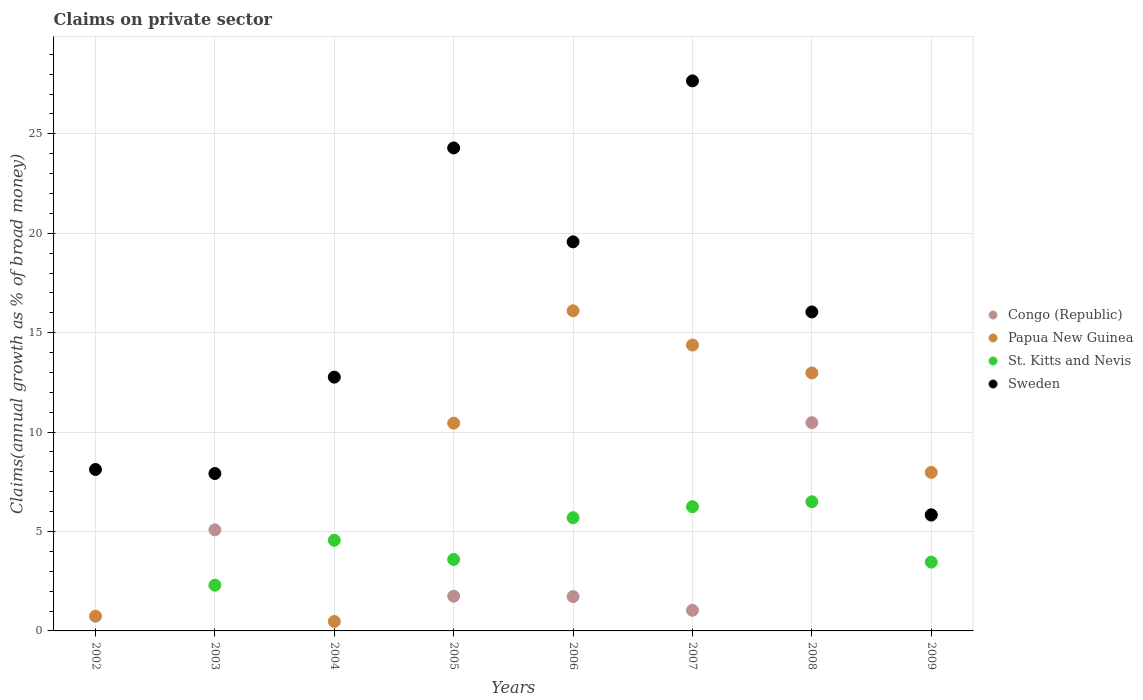How many different coloured dotlines are there?
Provide a short and direct response. 4. Is the number of dotlines equal to the number of legend labels?
Offer a terse response. No. What is the percentage of broad money claimed on private sector in Sweden in 2007?
Provide a succinct answer. 27.66. Across all years, what is the maximum percentage of broad money claimed on private sector in St. Kitts and Nevis?
Give a very brief answer. 6.5. Across all years, what is the minimum percentage of broad money claimed on private sector in Congo (Republic)?
Ensure brevity in your answer.  0. In which year was the percentage of broad money claimed on private sector in Congo (Republic) maximum?
Your answer should be compact. 2008. What is the total percentage of broad money claimed on private sector in St. Kitts and Nevis in the graph?
Your answer should be very brief. 32.35. What is the difference between the percentage of broad money claimed on private sector in Sweden in 2002 and that in 2007?
Give a very brief answer. -19.54. What is the difference between the percentage of broad money claimed on private sector in St. Kitts and Nevis in 2004 and the percentage of broad money claimed on private sector in Papua New Guinea in 2009?
Offer a terse response. -3.41. What is the average percentage of broad money claimed on private sector in Sweden per year?
Give a very brief answer. 15.28. In the year 2006, what is the difference between the percentage of broad money claimed on private sector in St. Kitts and Nevis and percentage of broad money claimed on private sector in Congo (Republic)?
Offer a very short reply. 3.97. What is the ratio of the percentage of broad money claimed on private sector in Sweden in 2007 to that in 2008?
Keep it short and to the point. 1.72. Is the percentage of broad money claimed on private sector in Papua New Guinea in 2006 less than that in 2008?
Your answer should be very brief. No. Is the difference between the percentage of broad money claimed on private sector in St. Kitts and Nevis in 2005 and 2006 greater than the difference between the percentage of broad money claimed on private sector in Congo (Republic) in 2005 and 2006?
Keep it short and to the point. No. What is the difference between the highest and the second highest percentage of broad money claimed on private sector in Papua New Guinea?
Offer a terse response. 1.72. What is the difference between the highest and the lowest percentage of broad money claimed on private sector in Congo (Republic)?
Your response must be concise. 10.47. In how many years, is the percentage of broad money claimed on private sector in Papua New Guinea greater than the average percentage of broad money claimed on private sector in Papua New Guinea taken over all years?
Offer a terse response. 5. Is the sum of the percentage of broad money claimed on private sector in Papua New Guinea in 2004 and 2007 greater than the maximum percentage of broad money claimed on private sector in Congo (Republic) across all years?
Keep it short and to the point. Yes. Is it the case that in every year, the sum of the percentage of broad money claimed on private sector in St. Kitts and Nevis and percentage of broad money claimed on private sector in Congo (Republic)  is greater than the sum of percentage of broad money claimed on private sector in Sweden and percentage of broad money claimed on private sector in Papua New Guinea?
Make the answer very short. No. Is the percentage of broad money claimed on private sector in St. Kitts and Nevis strictly greater than the percentage of broad money claimed on private sector in Congo (Republic) over the years?
Keep it short and to the point. No. Is the percentage of broad money claimed on private sector in Papua New Guinea strictly less than the percentage of broad money claimed on private sector in Sweden over the years?
Your answer should be very brief. No. Does the graph contain any zero values?
Provide a short and direct response. Yes. Where does the legend appear in the graph?
Ensure brevity in your answer.  Center right. How many legend labels are there?
Give a very brief answer. 4. What is the title of the graph?
Keep it short and to the point. Claims on private sector. Does "Middle East & North Africa (developing only)" appear as one of the legend labels in the graph?
Offer a terse response. No. What is the label or title of the Y-axis?
Provide a succinct answer. Claims(annual growth as % of broad money). What is the Claims(annual growth as % of broad money) of Congo (Republic) in 2002?
Provide a succinct answer. 0. What is the Claims(annual growth as % of broad money) of Papua New Guinea in 2002?
Offer a very short reply. 0.74. What is the Claims(annual growth as % of broad money) in St. Kitts and Nevis in 2002?
Provide a succinct answer. 0. What is the Claims(annual growth as % of broad money) of Sweden in 2002?
Ensure brevity in your answer.  8.12. What is the Claims(annual growth as % of broad money) in Congo (Republic) in 2003?
Your answer should be compact. 5.08. What is the Claims(annual growth as % of broad money) in Papua New Guinea in 2003?
Your response must be concise. 0. What is the Claims(annual growth as % of broad money) of St. Kitts and Nevis in 2003?
Give a very brief answer. 2.3. What is the Claims(annual growth as % of broad money) of Sweden in 2003?
Your answer should be compact. 7.92. What is the Claims(annual growth as % of broad money) of Congo (Republic) in 2004?
Ensure brevity in your answer.  0. What is the Claims(annual growth as % of broad money) of Papua New Guinea in 2004?
Give a very brief answer. 0.48. What is the Claims(annual growth as % of broad money) of St. Kitts and Nevis in 2004?
Your answer should be compact. 4.56. What is the Claims(annual growth as % of broad money) in Sweden in 2004?
Provide a short and direct response. 12.76. What is the Claims(annual growth as % of broad money) of Congo (Republic) in 2005?
Provide a short and direct response. 1.75. What is the Claims(annual growth as % of broad money) in Papua New Guinea in 2005?
Give a very brief answer. 10.45. What is the Claims(annual growth as % of broad money) in St. Kitts and Nevis in 2005?
Give a very brief answer. 3.6. What is the Claims(annual growth as % of broad money) of Sweden in 2005?
Offer a very short reply. 24.29. What is the Claims(annual growth as % of broad money) in Congo (Republic) in 2006?
Offer a very short reply. 1.73. What is the Claims(annual growth as % of broad money) in Papua New Guinea in 2006?
Provide a succinct answer. 16.1. What is the Claims(annual growth as % of broad money) in St. Kitts and Nevis in 2006?
Give a very brief answer. 5.69. What is the Claims(annual growth as % of broad money) in Sweden in 2006?
Provide a short and direct response. 19.57. What is the Claims(annual growth as % of broad money) in Congo (Republic) in 2007?
Offer a very short reply. 1.04. What is the Claims(annual growth as % of broad money) of Papua New Guinea in 2007?
Ensure brevity in your answer.  14.38. What is the Claims(annual growth as % of broad money) in St. Kitts and Nevis in 2007?
Give a very brief answer. 6.25. What is the Claims(annual growth as % of broad money) in Sweden in 2007?
Offer a terse response. 27.66. What is the Claims(annual growth as % of broad money) of Congo (Republic) in 2008?
Provide a succinct answer. 10.47. What is the Claims(annual growth as % of broad money) of Papua New Guinea in 2008?
Your response must be concise. 12.98. What is the Claims(annual growth as % of broad money) of St. Kitts and Nevis in 2008?
Keep it short and to the point. 6.5. What is the Claims(annual growth as % of broad money) of Sweden in 2008?
Offer a very short reply. 16.04. What is the Claims(annual growth as % of broad money) in Congo (Republic) in 2009?
Give a very brief answer. 5.81. What is the Claims(annual growth as % of broad money) in Papua New Guinea in 2009?
Your response must be concise. 7.97. What is the Claims(annual growth as % of broad money) of St. Kitts and Nevis in 2009?
Make the answer very short. 3.46. What is the Claims(annual growth as % of broad money) of Sweden in 2009?
Provide a short and direct response. 5.84. Across all years, what is the maximum Claims(annual growth as % of broad money) in Congo (Republic)?
Keep it short and to the point. 10.47. Across all years, what is the maximum Claims(annual growth as % of broad money) of Papua New Guinea?
Ensure brevity in your answer.  16.1. Across all years, what is the maximum Claims(annual growth as % of broad money) in St. Kitts and Nevis?
Provide a succinct answer. 6.5. Across all years, what is the maximum Claims(annual growth as % of broad money) of Sweden?
Your answer should be very brief. 27.66. Across all years, what is the minimum Claims(annual growth as % of broad money) in Congo (Republic)?
Offer a very short reply. 0. Across all years, what is the minimum Claims(annual growth as % of broad money) of Papua New Guinea?
Your answer should be compact. 0. Across all years, what is the minimum Claims(annual growth as % of broad money) of Sweden?
Keep it short and to the point. 5.84. What is the total Claims(annual growth as % of broad money) of Congo (Republic) in the graph?
Offer a very short reply. 25.88. What is the total Claims(annual growth as % of broad money) of Papua New Guinea in the graph?
Provide a succinct answer. 63.09. What is the total Claims(annual growth as % of broad money) of St. Kitts and Nevis in the graph?
Give a very brief answer. 32.35. What is the total Claims(annual growth as % of broad money) of Sweden in the graph?
Keep it short and to the point. 122.21. What is the difference between the Claims(annual growth as % of broad money) in Sweden in 2002 and that in 2003?
Provide a short and direct response. 0.2. What is the difference between the Claims(annual growth as % of broad money) in Papua New Guinea in 2002 and that in 2004?
Offer a terse response. 0.27. What is the difference between the Claims(annual growth as % of broad money) of Sweden in 2002 and that in 2004?
Your answer should be compact. -4.64. What is the difference between the Claims(annual growth as % of broad money) in Papua New Guinea in 2002 and that in 2005?
Offer a very short reply. -9.71. What is the difference between the Claims(annual growth as % of broad money) in Sweden in 2002 and that in 2005?
Offer a very short reply. -16.17. What is the difference between the Claims(annual growth as % of broad money) of Papua New Guinea in 2002 and that in 2006?
Provide a short and direct response. -15.36. What is the difference between the Claims(annual growth as % of broad money) in Sweden in 2002 and that in 2006?
Offer a terse response. -11.45. What is the difference between the Claims(annual growth as % of broad money) in Papua New Guinea in 2002 and that in 2007?
Keep it short and to the point. -13.64. What is the difference between the Claims(annual growth as % of broad money) of Sweden in 2002 and that in 2007?
Keep it short and to the point. -19.54. What is the difference between the Claims(annual growth as % of broad money) in Papua New Guinea in 2002 and that in 2008?
Provide a succinct answer. -12.24. What is the difference between the Claims(annual growth as % of broad money) of Sweden in 2002 and that in 2008?
Your response must be concise. -7.92. What is the difference between the Claims(annual growth as % of broad money) in Papua New Guinea in 2002 and that in 2009?
Offer a very short reply. -7.23. What is the difference between the Claims(annual growth as % of broad money) in Sweden in 2002 and that in 2009?
Offer a very short reply. 2.28. What is the difference between the Claims(annual growth as % of broad money) in St. Kitts and Nevis in 2003 and that in 2004?
Provide a short and direct response. -2.26. What is the difference between the Claims(annual growth as % of broad money) of Sweden in 2003 and that in 2004?
Your response must be concise. -4.85. What is the difference between the Claims(annual growth as % of broad money) of Congo (Republic) in 2003 and that in 2005?
Make the answer very short. 3.34. What is the difference between the Claims(annual growth as % of broad money) in St. Kitts and Nevis in 2003 and that in 2005?
Offer a very short reply. -1.3. What is the difference between the Claims(annual growth as % of broad money) of Sweden in 2003 and that in 2005?
Keep it short and to the point. -16.38. What is the difference between the Claims(annual growth as % of broad money) of Congo (Republic) in 2003 and that in 2006?
Make the answer very short. 3.36. What is the difference between the Claims(annual growth as % of broad money) in St. Kitts and Nevis in 2003 and that in 2006?
Your answer should be compact. -3.39. What is the difference between the Claims(annual growth as % of broad money) in Sweden in 2003 and that in 2006?
Ensure brevity in your answer.  -11.65. What is the difference between the Claims(annual growth as % of broad money) in Congo (Republic) in 2003 and that in 2007?
Offer a very short reply. 4.04. What is the difference between the Claims(annual growth as % of broad money) in St. Kitts and Nevis in 2003 and that in 2007?
Give a very brief answer. -3.95. What is the difference between the Claims(annual growth as % of broad money) of Sweden in 2003 and that in 2007?
Make the answer very short. -19.75. What is the difference between the Claims(annual growth as % of broad money) of Congo (Republic) in 2003 and that in 2008?
Make the answer very short. -5.39. What is the difference between the Claims(annual growth as % of broad money) of St. Kitts and Nevis in 2003 and that in 2008?
Offer a terse response. -4.2. What is the difference between the Claims(annual growth as % of broad money) of Sweden in 2003 and that in 2008?
Ensure brevity in your answer.  -8.13. What is the difference between the Claims(annual growth as % of broad money) of Congo (Republic) in 2003 and that in 2009?
Offer a very short reply. -0.73. What is the difference between the Claims(annual growth as % of broad money) of St. Kitts and Nevis in 2003 and that in 2009?
Provide a short and direct response. -1.16. What is the difference between the Claims(annual growth as % of broad money) of Sweden in 2003 and that in 2009?
Your answer should be compact. 2.07. What is the difference between the Claims(annual growth as % of broad money) of Papua New Guinea in 2004 and that in 2005?
Provide a short and direct response. -9.98. What is the difference between the Claims(annual growth as % of broad money) in St. Kitts and Nevis in 2004 and that in 2005?
Give a very brief answer. 0.96. What is the difference between the Claims(annual growth as % of broad money) of Sweden in 2004 and that in 2005?
Provide a short and direct response. -11.53. What is the difference between the Claims(annual growth as % of broad money) in Papua New Guinea in 2004 and that in 2006?
Provide a short and direct response. -15.62. What is the difference between the Claims(annual growth as % of broad money) of St. Kitts and Nevis in 2004 and that in 2006?
Ensure brevity in your answer.  -1.13. What is the difference between the Claims(annual growth as % of broad money) of Sweden in 2004 and that in 2006?
Make the answer very short. -6.8. What is the difference between the Claims(annual growth as % of broad money) of Papua New Guinea in 2004 and that in 2007?
Provide a short and direct response. -13.9. What is the difference between the Claims(annual growth as % of broad money) of St. Kitts and Nevis in 2004 and that in 2007?
Provide a short and direct response. -1.69. What is the difference between the Claims(annual growth as % of broad money) of Sweden in 2004 and that in 2007?
Your answer should be compact. -14.9. What is the difference between the Claims(annual growth as % of broad money) in Papua New Guinea in 2004 and that in 2008?
Your response must be concise. -12.5. What is the difference between the Claims(annual growth as % of broad money) in St. Kitts and Nevis in 2004 and that in 2008?
Provide a succinct answer. -1.94. What is the difference between the Claims(annual growth as % of broad money) of Sweden in 2004 and that in 2008?
Your response must be concise. -3.28. What is the difference between the Claims(annual growth as % of broad money) in Papua New Guinea in 2004 and that in 2009?
Your answer should be very brief. -7.5. What is the difference between the Claims(annual growth as % of broad money) of St. Kitts and Nevis in 2004 and that in 2009?
Ensure brevity in your answer.  1.1. What is the difference between the Claims(annual growth as % of broad money) in Sweden in 2004 and that in 2009?
Your answer should be compact. 6.92. What is the difference between the Claims(annual growth as % of broad money) of Congo (Republic) in 2005 and that in 2006?
Give a very brief answer. 0.02. What is the difference between the Claims(annual growth as % of broad money) of Papua New Guinea in 2005 and that in 2006?
Give a very brief answer. -5.65. What is the difference between the Claims(annual growth as % of broad money) of St. Kitts and Nevis in 2005 and that in 2006?
Keep it short and to the point. -2.1. What is the difference between the Claims(annual growth as % of broad money) of Sweden in 2005 and that in 2006?
Provide a short and direct response. 4.72. What is the difference between the Claims(annual growth as % of broad money) of Congo (Republic) in 2005 and that in 2007?
Give a very brief answer. 0.71. What is the difference between the Claims(annual growth as % of broad money) in Papua New Guinea in 2005 and that in 2007?
Make the answer very short. -3.93. What is the difference between the Claims(annual growth as % of broad money) in St. Kitts and Nevis in 2005 and that in 2007?
Give a very brief answer. -2.65. What is the difference between the Claims(annual growth as % of broad money) in Sweden in 2005 and that in 2007?
Offer a terse response. -3.37. What is the difference between the Claims(annual growth as % of broad money) in Congo (Republic) in 2005 and that in 2008?
Your answer should be compact. -8.73. What is the difference between the Claims(annual growth as % of broad money) of Papua New Guinea in 2005 and that in 2008?
Ensure brevity in your answer.  -2.53. What is the difference between the Claims(annual growth as % of broad money) in St. Kitts and Nevis in 2005 and that in 2008?
Give a very brief answer. -2.9. What is the difference between the Claims(annual growth as % of broad money) of Sweden in 2005 and that in 2008?
Provide a short and direct response. 8.25. What is the difference between the Claims(annual growth as % of broad money) in Congo (Republic) in 2005 and that in 2009?
Your answer should be compact. -4.06. What is the difference between the Claims(annual growth as % of broad money) in Papua New Guinea in 2005 and that in 2009?
Keep it short and to the point. 2.48. What is the difference between the Claims(annual growth as % of broad money) in St. Kitts and Nevis in 2005 and that in 2009?
Your answer should be compact. 0.14. What is the difference between the Claims(annual growth as % of broad money) of Sweden in 2005 and that in 2009?
Ensure brevity in your answer.  18.45. What is the difference between the Claims(annual growth as % of broad money) of Congo (Republic) in 2006 and that in 2007?
Make the answer very short. 0.69. What is the difference between the Claims(annual growth as % of broad money) in Papua New Guinea in 2006 and that in 2007?
Offer a terse response. 1.72. What is the difference between the Claims(annual growth as % of broad money) in St. Kitts and Nevis in 2006 and that in 2007?
Keep it short and to the point. -0.55. What is the difference between the Claims(annual growth as % of broad money) of Sweden in 2006 and that in 2007?
Provide a short and direct response. -8.09. What is the difference between the Claims(annual growth as % of broad money) in Congo (Republic) in 2006 and that in 2008?
Ensure brevity in your answer.  -8.75. What is the difference between the Claims(annual growth as % of broad money) of Papua New Guinea in 2006 and that in 2008?
Your response must be concise. 3.12. What is the difference between the Claims(annual growth as % of broad money) of St. Kitts and Nevis in 2006 and that in 2008?
Give a very brief answer. -0.8. What is the difference between the Claims(annual growth as % of broad money) in Sweden in 2006 and that in 2008?
Your response must be concise. 3.53. What is the difference between the Claims(annual growth as % of broad money) in Congo (Republic) in 2006 and that in 2009?
Ensure brevity in your answer.  -4.08. What is the difference between the Claims(annual growth as % of broad money) in Papua New Guinea in 2006 and that in 2009?
Your answer should be very brief. 8.13. What is the difference between the Claims(annual growth as % of broad money) in St. Kitts and Nevis in 2006 and that in 2009?
Provide a succinct answer. 2.23. What is the difference between the Claims(annual growth as % of broad money) of Sweden in 2006 and that in 2009?
Ensure brevity in your answer.  13.73. What is the difference between the Claims(annual growth as % of broad money) in Congo (Republic) in 2007 and that in 2008?
Your answer should be compact. -9.44. What is the difference between the Claims(annual growth as % of broad money) of Papua New Guinea in 2007 and that in 2008?
Offer a terse response. 1.4. What is the difference between the Claims(annual growth as % of broad money) in St. Kitts and Nevis in 2007 and that in 2008?
Your answer should be very brief. -0.25. What is the difference between the Claims(annual growth as % of broad money) in Sweden in 2007 and that in 2008?
Your answer should be compact. 11.62. What is the difference between the Claims(annual growth as % of broad money) of Congo (Republic) in 2007 and that in 2009?
Keep it short and to the point. -4.77. What is the difference between the Claims(annual growth as % of broad money) of Papua New Guinea in 2007 and that in 2009?
Keep it short and to the point. 6.41. What is the difference between the Claims(annual growth as % of broad money) in St. Kitts and Nevis in 2007 and that in 2009?
Your answer should be compact. 2.79. What is the difference between the Claims(annual growth as % of broad money) of Sweden in 2007 and that in 2009?
Give a very brief answer. 21.82. What is the difference between the Claims(annual growth as % of broad money) of Congo (Republic) in 2008 and that in 2009?
Make the answer very short. 4.67. What is the difference between the Claims(annual growth as % of broad money) in Papua New Guinea in 2008 and that in 2009?
Provide a short and direct response. 5. What is the difference between the Claims(annual growth as % of broad money) in St. Kitts and Nevis in 2008 and that in 2009?
Keep it short and to the point. 3.04. What is the difference between the Claims(annual growth as % of broad money) in Sweden in 2008 and that in 2009?
Make the answer very short. 10.2. What is the difference between the Claims(annual growth as % of broad money) of Papua New Guinea in 2002 and the Claims(annual growth as % of broad money) of St. Kitts and Nevis in 2003?
Give a very brief answer. -1.56. What is the difference between the Claims(annual growth as % of broad money) in Papua New Guinea in 2002 and the Claims(annual growth as % of broad money) in Sweden in 2003?
Give a very brief answer. -7.18. What is the difference between the Claims(annual growth as % of broad money) in Papua New Guinea in 2002 and the Claims(annual growth as % of broad money) in St. Kitts and Nevis in 2004?
Keep it short and to the point. -3.82. What is the difference between the Claims(annual growth as % of broad money) in Papua New Guinea in 2002 and the Claims(annual growth as % of broad money) in Sweden in 2004?
Provide a short and direct response. -12.02. What is the difference between the Claims(annual growth as % of broad money) in Papua New Guinea in 2002 and the Claims(annual growth as % of broad money) in St. Kitts and Nevis in 2005?
Provide a succinct answer. -2.85. What is the difference between the Claims(annual growth as % of broad money) of Papua New Guinea in 2002 and the Claims(annual growth as % of broad money) of Sweden in 2005?
Your response must be concise. -23.55. What is the difference between the Claims(annual growth as % of broad money) in Papua New Guinea in 2002 and the Claims(annual growth as % of broad money) in St. Kitts and Nevis in 2006?
Keep it short and to the point. -4.95. What is the difference between the Claims(annual growth as % of broad money) of Papua New Guinea in 2002 and the Claims(annual growth as % of broad money) of Sweden in 2006?
Offer a terse response. -18.83. What is the difference between the Claims(annual growth as % of broad money) of Papua New Guinea in 2002 and the Claims(annual growth as % of broad money) of St. Kitts and Nevis in 2007?
Make the answer very short. -5.51. What is the difference between the Claims(annual growth as % of broad money) of Papua New Guinea in 2002 and the Claims(annual growth as % of broad money) of Sweden in 2007?
Make the answer very short. -26.92. What is the difference between the Claims(annual growth as % of broad money) in Papua New Guinea in 2002 and the Claims(annual growth as % of broad money) in St. Kitts and Nevis in 2008?
Offer a terse response. -5.75. What is the difference between the Claims(annual growth as % of broad money) of Papua New Guinea in 2002 and the Claims(annual growth as % of broad money) of Sweden in 2008?
Give a very brief answer. -15.3. What is the difference between the Claims(annual growth as % of broad money) of Papua New Guinea in 2002 and the Claims(annual growth as % of broad money) of St. Kitts and Nevis in 2009?
Your answer should be compact. -2.72. What is the difference between the Claims(annual growth as % of broad money) in Papua New Guinea in 2002 and the Claims(annual growth as % of broad money) in Sweden in 2009?
Your answer should be compact. -5.1. What is the difference between the Claims(annual growth as % of broad money) in Congo (Republic) in 2003 and the Claims(annual growth as % of broad money) in Papua New Guinea in 2004?
Your answer should be compact. 4.61. What is the difference between the Claims(annual growth as % of broad money) of Congo (Republic) in 2003 and the Claims(annual growth as % of broad money) of St. Kitts and Nevis in 2004?
Your response must be concise. 0.52. What is the difference between the Claims(annual growth as % of broad money) in Congo (Republic) in 2003 and the Claims(annual growth as % of broad money) in Sweden in 2004?
Ensure brevity in your answer.  -7.68. What is the difference between the Claims(annual growth as % of broad money) of St. Kitts and Nevis in 2003 and the Claims(annual growth as % of broad money) of Sweden in 2004?
Provide a succinct answer. -10.46. What is the difference between the Claims(annual growth as % of broad money) of Congo (Republic) in 2003 and the Claims(annual growth as % of broad money) of Papua New Guinea in 2005?
Provide a succinct answer. -5.37. What is the difference between the Claims(annual growth as % of broad money) of Congo (Republic) in 2003 and the Claims(annual growth as % of broad money) of St. Kitts and Nevis in 2005?
Provide a succinct answer. 1.49. What is the difference between the Claims(annual growth as % of broad money) in Congo (Republic) in 2003 and the Claims(annual growth as % of broad money) in Sweden in 2005?
Keep it short and to the point. -19.21. What is the difference between the Claims(annual growth as % of broad money) in St. Kitts and Nevis in 2003 and the Claims(annual growth as % of broad money) in Sweden in 2005?
Your answer should be compact. -21.99. What is the difference between the Claims(annual growth as % of broad money) in Congo (Republic) in 2003 and the Claims(annual growth as % of broad money) in Papua New Guinea in 2006?
Make the answer very short. -11.02. What is the difference between the Claims(annual growth as % of broad money) in Congo (Republic) in 2003 and the Claims(annual growth as % of broad money) in St. Kitts and Nevis in 2006?
Make the answer very short. -0.61. What is the difference between the Claims(annual growth as % of broad money) of Congo (Republic) in 2003 and the Claims(annual growth as % of broad money) of Sweden in 2006?
Make the answer very short. -14.49. What is the difference between the Claims(annual growth as % of broad money) of St. Kitts and Nevis in 2003 and the Claims(annual growth as % of broad money) of Sweden in 2006?
Provide a short and direct response. -17.27. What is the difference between the Claims(annual growth as % of broad money) of Congo (Republic) in 2003 and the Claims(annual growth as % of broad money) of Papua New Guinea in 2007?
Ensure brevity in your answer.  -9.3. What is the difference between the Claims(annual growth as % of broad money) in Congo (Republic) in 2003 and the Claims(annual growth as % of broad money) in St. Kitts and Nevis in 2007?
Provide a short and direct response. -1.16. What is the difference between the Claims(annual growth as % of broad money) in Congo (Republic) in 2003 and the Claims(annual growth as % of broad money) in Sweden in 2007?
Ensure brevity in your answer.  -22.58. What is the difference between the Claims(annual growth as % of broad money) of St. Kitts and Nevis in 2003 and the Claims(annual growth as % of broad money) of Sweden in 2007?
Your answer should be compact. -25.36. What is the difference between the Claims(annual growth as % of broad money) of Congo (Republic) in 2003 and the Claims(annual growth as % of broad money) of Papua New Guinea in 2008?
Keep it short and to the point. -7.89. What is the difference between the Claims(annual growth as % of broad money) in Congo (Republic) in 2003 and the Claims(annual growth as % of broad money) in St. Kitts and Nevis in 2008?
Offer a terse response. -1.41. What is the difference between the Claims(annual growth as % of broad money) in Congo (Republic) in 2003 and the Claims(annual growth as % of broad money) in Sweden in 2008?
Give a very brief answer. -10.96. What is the difference between the Claims(annual growth as % of broad money) in St. Kitts and Nevis in 2003 and the Claims(annual growth as % of broad money) in Sweden in 2008?
Provide a succinct answer. -13.74. What is the difference between the Claims(annual growth as % of broad money) of Congo (Republic) in 2003 and the Claims(annual growth as % of broad money) of Papua New Guinea in 2009?
Your response must be concise. -2.89. What is the difference between the Claims(annual growth as % of broad money) of Congo (Republic) in 2003 and the Claims(annual growth as % of broad money) of St. Kitts and Nevis in 2009?
Offer a very short reply. 1.62. What is the difference between the Claims(annual growth as % of broad money) in Congo (Republic) in 2003 and the Claims(annual growth as % of broad money) in Sweden in 2009?
Make the answer very short. -0.76. What is the difference between the Claims(annual growth as % of broad money) of St. Kitts and Nevis in 2003 and the Claims(annual growth as % of broad money) of Sweden in 2009?
Ensure brevity in your answer.  -3.54. What is the difference between the Claims(annual growth as % of broad money) of Papua New Guinea in 2004 and the Claims(annual growth as % of broad money) of St. Kitts and Nevis in 2005?
Keep it short and to the point. -3.12. What is the difference between the Claims(annual growth as % of broad money) of Papua New Guinea in 2004 and the Claims(annual growth as % of broad money) of Sweden in 2005?
Provide a succinct answer. -23.82. What is the difference between the Claims(annual growth as % of broad money) in St. Kitts and Nevis in 2004 and the Claims(annual growth as % of broad money) in Sweden in 2005?
Your answer should be very brief. -19.73. What is the difference between the Claims(annual growth as % of broad money) in Papua New Guinea in 2004 and the Claims(annual growth as % of broad money) in St. Kitts and Nevis in 2006?
Provide a short and direct response. -5.22. What is the difference between the Claims(annual growth as % of broad money) of Papua New Guinea in 2004 and the Claims(annual growth as % of broad money) of Sweden in 2006?
Provide a succinct answer. -19.09. What is the difference between the Claims(annual growth as % of broad money) of St. Kitts and Nevis in 2004 and the Claims(annual growth as % of broad money) of Sweden in 2006?
Offer a terse response. -15.01. What is the difference between the Claims(annual growth as % of broad money) in Papua New Guinea in 2004 and the Claims(annual growth as % of broad money) in St. Kitts and Nevis in 2007?
Provide a succinct answer. -5.77. What is the difference between the Claims(annual growth as % of broad money) of Papua New Guinea in 2004 and the Claims(annual growth as % of broad money) of Sweden in 2007?
Offer a terse response. -27.19. What is the difference between the Claims(annual growth as % of broad money) of St. Kitts and Nevis in 2004 and the Claims(annual growth as % of broad money) of Sweden in 2007?
Make the answer very short. -23.1. What is the difference between the Claims(annual growth as % of broad money) in Papua New Guinea in 2004 and the Claims(annual growth as % of broad money) in St. Kitts and Nevis in 2008?
Your answer should be compact. -6.02. What is the difference between the Claims(annual growth as % of broad money) in Papua New Guinea in 2004 and the Claims(annual growth as % of broad money) in Sweden in 2008?
Your answer should be compact. -15.57. What is the difference between the Claims(annual growth as % of broad money) in St. Kitts and Nevis in 2004 and the Claims(annual growth as % of broad money) in Sweden in 2008?
Ensure brevity in your answer.  -11.48. What is the difference between the Claims(annual growth as % of broad money) of Papua New Guinea in 2004 and the Claims(annual growth as % of broad money) of St. Kitts and Nevis in 2009?
Offer a terse response. -2.98. What is the difference between the Claims(annual growth as % of broad money) of Papua New Guinea in 2004 and the Claims(annual growth as % of broad money) of Sweden in 2009?
Your answer should be compact. -5.37. What is the difference between the Claims(annual growth as % of broad money) of St. Kitts and Nevis in 2004 and the Claims(annual growth as % of broad money) of Sweden in 2009?
Offer a very short reply. -1.28. What is the difference between the Claims(annual growth as % of broad money) in Congo (Republic) in 2005 and the Claims(annual growth as % of broad money) in Papua New Guinea in 2006?
Give a very brief answer. -14.35. What is the difference between the Claims(annual growth as % of broad money) in Congo (Republic) in 2005 and the Claims(annual growth as % of broad money) in St. Kitts and Nevis in 2006?
Offer a very short reply. -3.95. What is the difference between the Claims(annual growth as % of broad money) in Congo (Republic) in 2005 and the Claims(annual growth as % of broad money) in Sweden in 2006?
Provide a short and direct response. -17.82. What is the difference between the Claims(annual growth as % of broad money) of Papua New Guinea in 2005 and the Claims(annual growth as % of broad money) of St. Kitts and Nevis in 2006?
Your answer should be very brief. 4.76. What is the difference between the Claims(annual growth as % of broad money) of Papua New Guinea in 2005 and the Claims(annual growth as % of broad money) of Sweden in 2006?
Your answer should be very brief. -9.12. What is the difference between the Claims(annual growth as % of broad money) of St. Kitts and Nevis in 2005 and the Claims(annual growth as % of broad money) of Sweden in 2006?
Your answer should be compact. -15.97. What is the difference between the Claims(annual growth as % of broad money) in Congo (Republic) in 2005 and the Claims(annual growth as % of broad money) in Papua New Guinea in 2007?
Keep it short and to the point. -12.63. What is the difference between the Claims(annual growth as % of broad money) in Congo (Republic) in 2005 and the Claims(annual growth as % of broad money) in St. Kitts and Nevis in 2007?
Provide a short and direct response. -4.5. What is the difference between the Claims(annual growth as % of broad money) in Congo (Republic) in 2005 and the Claims(annual growth as % of broad money) in Sweden in 2007?
Your answer should be very brief. -25.92. What is the difference between the Claims(annual growth as % of broad money) of Papua New Guinea in 2005 and the Claims(annual growth as % of broad money) of St. Kitts and Nevis in 2007?
Offer a very short reply. 4.2. What is the difference between the Claims(annual growth as % of broad money) of Papua New Guinea in 2005 and the Claims(annual growth as % of broad money) of Sweden in 2007?
Make the answer very short. -17.21. What is the difference between the Claims(annual growth as % of broad money) of St. Kitts and Nevis in 2005 and the Claims(annual growth as % of broad money) of Sweden in 2007?
Give a very brief answer. -24.07. What is the difference between the Claims(annual growth as % of broad money) of Congo (Republic) in 2005 and the Claims(annual growth as % of broad money) of Papua New Guinea in 2008?
Your answer should be compact. -11.23. What is the difference between the Claims(annual growth as % of broad money) of Congo (Republic) in 2005 and the Claims(annual growth as % of broad money) of St. Kitts and Nevis in 2008?
Keep it short and to the point. -4.75. What is the difference between the Claims(annual growth as % of broad money) of Congo (Republic) in 2005 and the Claims(annual growth as % of broad money) of Sweden in 2008?
Make the answer very short. -14.3. What is the difference between the Claims(annual growth as % of broad money) of Papua New Guinea in 2005 and the Claims(annual growth as % of broad money) of St. Kitts and Nevis in 2008?
Provide a short and direct response. 3.95. What is the difference between the Claims(annual growth as % of broad money) in Papua New Guinea in 2005 and the Claims(annual growth as % of broad money) in Sweden in 2008?
Give a very brief answer. -5.59. What is the difference between the Claims(annual growth as % of broad money) in St. Kitts and Nevis in 2005 and the Claims(annual growth as % of broad money) in Sweden in 2008?
Your answer should be very brief. -12.45. What is the difference between the Claims(annual growth as % of broad money) of Congo (Republic) in 2005 and the Claims(annual growth as % of broad money) of Papua New Guinea in 2009?
Ensure brevity in your answer.  -6.23. What is the difference between the Claims(annual growth as % of broad money) of Congo (Republic) in 2005 and the Claims(annual growth as % of broad money) of St. Kitts and Nevis in 2009?
Your answer should be very brief. -1.71. What is the difference between the Claims(annual growth as % of broad money) in Congo (Republic) in 2005 and the Claims(annual growth as % of broad money) in Sweden in 2009?
Your answer should be compact. -4.1. What is the difference between the Claims(annual growth as % of broad money) in Papua New Guinea in 2005 and the Claims(annual growth as % of broad money) in St. Kitts and Nevis in 2009?
Your response must be concise. 6.99. What is the difference between the Claims(annual growth as % of broad money) in Papua New Guinea in 2005 and the Claims(annual growth as % of broad money) in Sweden in 2009?
Offer a very short reply. 4.61. What is the difference between the Claims(annual growth as % of broad money) in St. Kitts and Nevis in 2005 and the Claims(annual growth as % of broad money) in Sweden in 2009?
Your response must be concise. -2.25. What is the difference between the Claims(annual growth as % of broad money) of Congo (Republic) in 2006 and the Claims(annual growth as % of broad money) of Papua New Guinea in 2007?
Your response must be concise. -12.65. What is the difference between the Claims(annual growth as % of broad money) in Congo (Republic) in 2006 and the Claims(annual growth as % of broad money) in St. Kitts and Nevis in 2007?
Provide a short and direct response. -4.52. What is the difference between the Claims(annual growth as % of broad money) of Congo (Republic) in 2006 and the Claims(annual growth as % of broad money) of Sweden in 2007?
Give a very brief answer. -25.94. What is the difference between the Claims(annual growth as % of broad money) of Papua New Guinea in 2006 and the Claims(annual growth as % of broad money) of St. Kitts and Nevis in 2007?
Your response must be concise. 9.85. What is the difference between the Claims(annual growth as % of broad money) in Papua New Guinea in 2006 and the Claims(annual growth as % of broad money) in Sweden in 2007?
Ensure brevity in your answer.  -11.56. What is the difference between the Claims(annual growth as % of broad money) of St. Kitts and Nevis in 2006 and the Claims(annual growth as % of broad money) of Sweden in 2007?
Your answer should be very brief. -21.97. What is the difference between the Claims(annual growth as % of broad money) of Congo (Republic) in 2006 and the Claims(annual growth as % of broad money) of Papua New Guinea in 2008?
Your response must be concise. -11.25. What is the difference between the Claims(annual growth as % of broad money) in Congo (Republic) in 2006 and the Claims(annual growth as % of broad money) in St. Kitts and Nevis in 2008?
Make the answer very short. -4.77. What is the difference between the Claims(annual growth as % of broad money) of Congo (Republic) in 2006 and the Claims(annual growth as % of broad money) of Sweden in 2008?
Your answer should be compact. -14.32. What is the difference between the Claims(annual growth as % of broad money) in Papua New Guinea in 2006 and the Claims(annual growth as % of broad money) in St. Kitts and Nevis in 2008?
Ensure brevity in your answer.  9.6. What is the difference between the Claims(annual growth as % of broad money) of Papua New Guinea in 2006 and the Claims(annual growth as % of broad money) of Sweden in 2008?
Ensure brevity in your answer.  0.06. What is the difference between the Claims(annual growth as % of broad money) of St. Kitts and Nevis in 2006 and the Claims(annual growth as % of broad money) of Sweden in 2008?
Your response must be concise. -10.35. What is the difference between the Claims(annual growth as % of broad money) in Congo (Republic) in 2006 and the Claims(annual growth as % of broad money) in Papua New Guinea in 2009?
Give a very brief answer. -6.25. What is the difference between the Claims(annual growth as % of broad money) in Congo (Republic) in 2006 and the Claims(annual growth as % of broad money) in St. Kitts and Nevis in 2009?
Keep it short and to the point. -1.73. What is the difference between the Claims(annual growth as % of broad money) in Congo (Republic) in 2006 and the Claims(annual growth as % of broad money) in Sweden in 2009?
Keep it short and to the point. -4.12. What is the difference between the Claims(annual growth as % of broad money) in Papua New Guinea in 2006 and the Claims(annual growth as % of broad money) in St. Kitts and Nevis in 2009?
Your answer should be compact. 12.64. What is the difference between the Claims(annual growth as % of broad money) of Papua New Guinea in 2006 and the Claims(annual growth as % of broad money) of Sweden in 2009?
Make the answer very short. 10.26. What is the difference between the Claims(annual growth as % of broad money) in St. Kitts and Nevis in 2006 and the Claims(annual growth as % of broad money) in Sweden in 2009?
Offer a terse response. -0.15. What is the difference between the Claims(annual growth as % of broad money) in Congo (Republic) in 2007 and the Claims(annual growth as % of broad money) in Papua New Guinea in 2008?
Ensure brevity in your answer.  -11.94. What is the difference between the Claims(annual growth as % of broad money) of Congo (Republic) in 2007 and the Claims(annual growth as % of broad money) of St. Kitts and Nevis in 2008?
Your answer should be very brief. -5.46. What is the difference between the Claims(annual growth as % of broad money) in Congo (Republic) in 2007 and the Claims(annual growth as % of broad money) in Sweden in 2008?
Your answer should be very brief. -15. What is the difference between the Claims(annual growth as % of broad money) of Papua New Guinea in 2007 and the Claims(annual growth as % of broad money) of St. Kitts and Nevis in 2008?
Provide a short and direct response. 7.88. What is the difference between the Claims(annual growth as % of broad money) of Papua New Guinea in 2007 and the Claims(annual growth as % of broad money) of Sweden in 2008?
Keep it short and to the point. -1.66. What is the difference between the Claims(annual growth as % of broad money) in St. Kitts and Nevis in 2007 and the Claims(annual growth as % of broad money) in Sweden in 2008?
Make the answer very short. -9.79. What is the difference between the Claims(annual growth as % of broad money) of Congo (Republic) in 2007 and the Claims(annual growth as % of broad money) of Papua New Guinea in 2009?
Your answer should be compact. -6.93. What is the difference between the Claims(annual growth as % of broad money) in Congo (Republic) in 2007 and the Claims(annual growth as % of broad money) in St. Kitts and Nevis in 2009?
Your answer should be compact. -2.42. What is the difference between the Claims(annual growth as % of broad money) in Congo (Republic) in 2007 and the Claims(annual growth as % of broad money) in Sweden in 2009?
Provide a short and direct response. -4.8. What is the difference between the Claims(annual growth as % of broad money) in Papua New Guinea in 2007 and the Claims(annual growth as % of broad money) in St. Kitts and Nevis in 2009?
Provide a succinct answer. 10.92. What is the difference between the Claims(annual growth as % of broad money) of Papua New Guinea in 2007 and the Claims(annual growth as % of broad money) of Sweden in 2009?
Provide a succinct answer. 8.54. What is the difference between the Claims(annual growth as % of broad money) of St. Kitts and Nevis in 2007 and the Claims(annual growth as % of broad money) of Sweden in 2009?
Your answer should be very brief. 0.41. What is the difference between the Claims(annual growth as % of broad money) of Congo (Republic) in 2008 and the Claims(annual growth as % of broad money) of Papua New Guinea in 2009?
Your response must be concise. 2.5. What is the difference between the Claims(annual growth as % of broad money) of Congo (Republic) in 2008 and the Claims(annual growth as % of broad money) of St. Kitts and Nevis in 2009?
Keep it short and to the point. 7.02. What is the difference between the Claims(annual growth as % of broad money) of Congo (Republic) in 2008 and the Claims(annual growth as % of broad money) of Sweden in 2009?
Offer a very short reply. 4.63. What is the difference between the Claims(annual growth as % of broad money) of Papua New Guinea in 2008 and the Claims(annual growth as % of broad money) of St. Kitts and Nevis in 2009?
Offer a very short reply. 9.52. What is the difference between the Claims(annual growth as % of broad money) of Papua New Guinea in 2008 and the Claims(annual growth as % of broad money) of Sweden in 2009?
Your answer should be compact. 7.13. What is the difference between the Claims(annual growth as % of broad money) of St. Kitts and Nevis in 2008 and the Claims(annual growth as % of broad money) of Sweden in 2009?
Provide a succinct answer. 0.65. What is the average Claims(annual growth as % of broad money) of Congo (Republic) per year?
Provide a short and direct response. 3.23. What is the average Claims(annual growth as % of broad money) of Papua New Guinea per year?
Provide a short and direct response. 7.89. What is the average Claims(annual growth as % of broad money) in St. Kitts and Nevis per year?
Make the answer very short. 4.04. What is the average Claims(annual growth as % of broad money) in Sweden per year?
Ensure brevity in your answer.  15.28. In the year 2002, what is the difference between the Claims(annual growth as % of broad money) of Papua New Guinea and Claims(annual growth as % of broad money) of Sweden?
Keep it short and to the point. -7.38. In the year 2003, what is the difference between the Claims(annual growth as % of broad money) in Congo (Republic) and Claims(annual growth as % of broad money) in St. Kitts and Nevis?
Make the answer very short. 2.78. In the year 2003, what is the difference between the Claims(annual growth as % of broad money) of Congo (Republic) and Claims(annual growth as % of broad money) of Sweden?
Ensure brevity in your answer.  -2.83. In the year 2003, what is the difference between the Claims(annual growth as % of broad money) of St. Kitts and Nevis and Claims(annual growth as % of broad money) of Sweden?
Your answer should be compact. -5.62. In the year 2004, what is the difference between the Claims(annual growth as % of broad money) of Papua New Guinea and Claims(annual growth as % of broad money) of St. Kitts and Nevis?
Make the answer very short. -4.08. In the year 2004, what is the difference between the Claims(annual growth as % of broad money) in Papua New Guinea and Claims(annual growth as % of broad money) in Sweden?
Ensure brevity in your answer.  -12.29. In the year 2004, what is the difference between the Claims(annual growth as % of broad money) of St. Kitts and Nevis and Claims(annual growth as % of broad money) of Sweden?
Provide a short and direct response. -8.2. In the year 2005, what is the difference between the Claims(annual growth as % of broad money) in Congo (Republic) and Claims(annual growth as % of broad money) in Papua New Guinea?
Keep it short and to the point. -8.7. In the year 2005, what is the difference between the Claims(annual growth as % of broad money) of Congo (Republic) and Claims(annual growth as % of broad money) of St. Kitts and Nevis?
Ensure brevity in your answer.  -1.85. In the year 2005, what is the difference between the Claims(annual growth as % of broad money) of Congo (Republic) and Claims(annual growth as % of broad money) of Sweden?
Your response must be concise. -22.55. In the year 2005, what is the difference between the Claims(annual growth as % of broad money) in Papua New Guinea and Claims(annual growth as % of broad money) in St. Kitts and Nevis?
Provide a succinct answer. 6.86. In the year 2005, what is the difference between the Claims(annual growth as % of broad money) in Papua New Guinea and Claims(annual growth as % of broad money) in Sweden?
Your answer should be compact. -13.84. In the year 2005, what is the difference between the Claims(annual growth as % of broad money) in St. Kitts and Nevis and Claims(annual growth as % of broad money) in Sweden?
Make the answer very short. -20.7. In the year 2006, what is the difference between the Claims(annual growth as % of broad money) in Congo (Republic) and Claims(annual growth as % of broad money) in Papua New Guinea?
Offer a very short reply. -14.37. In the year 2006, what is the difference between the Claims(annual growth as % of broad money) in Congo (Republic) and Claims(annual growth as % of broad money) in St. Kitts and Nevis?
Provide a succinct answer. -3.97. In the year 2006, what is the difference between the Claims(annual growth as % of broad money) in Congo (Republic) and Claims(annual growth as % of broad money) in Sweden?
Provide a short and direct response. -17.84. In the year 2006, what is the difference between the Claims(annual growth as % of broad money) in Papua New Guinea and Claims(annual growth as % of broad money) in St. Kitts and Nevis?
Your answer should be very brief. 10.41. In the year 2006, what is the difference between the Claims(annual growth as % of broad money) of Papua New Guinea and Claims(annual growth as % of broad money) of Sweden?
Ensure brevity in your answer.  -3.47. In the year 2006, what is the difference between the Claims(annual growth as % of broad money) of St. Kitts and Nevis and Claims(annual growth as % of broad money) of Sweden?
Give a very brief answer. -13.88. In the year 2007, what is the difference between the Claims(annual growth as % of broad money) of Congo (Republic) and Claims(annual growth as % of broad money) of Papua New Guinea?
Your answer should be compact. -13.34. In the year 2007, what is the difference between the Claims(annual growth as % of broad money) in Congo (Republic) and Claims(annual growth as % of broad money) in St. Kitts and Nevis?
Ensure brevity in your answer.  -5.21. In the year 2007, what is the difference between the Claims(annual growth as % of broad money) of Congo (Republic) and Claims(annual growth as % of broad money) of Sweden?
Give a very brief answer. -26.63. In the year 2007, what is the difference between the Claims(annual growth as % of broad money) in Papua New Guinea and Claims(annual growth as % of broad money) in St. Kitts and Nevis?
Ensure brevity in your answer.  8.13. In the year 2007, what is the difference between the Claims(annual growth as % of broad money) in Papua New Guinea and Claims(annual growth as % of broad money) in Sweden?
Your answer should be very brief. -13.29. In the year 2007, what is the difference between the Claims(annual growth as % of broad money) in St. Kitts and Nevis and Claims(annual growth as % of broad money) in Sweden?
Give a very brief answer. -21.42. In the year 2008, what is the difference between the Claims(annual growth as % of broad money) of Congo (Republic) and Claims(annual growth as % of broad money) of Papua New Guinea?
Provide a short and direct response. -2.5. In the year 2008, what is the difference between the Claims(annual growth as % of broad money) of Congo (Republic) and Claims(annual growth as % of broad money) of St. Kitts and Nevis?
Make the answer very short. 3.98. In the year 2008, what is the difference between the Claims(annual growth as % of broad money) of Congo (Republic) and Claims(annual growth as % of broad money) of Sweden?
Your answer should be compact. -5.57. In the year 2008, what is the difference between the Claims(annual growth as % of broad money) of Papua New Guinea and Claims(annual growth as % of broad money) of St. Kitts and Nevis?
Give a very brief answer. 6.48. In the year 2008, what is the difference between the Claims(annual growth as % of broad money) in Papua New Guinea and Claims(annual growth as % of broad money) in Sweden?
Your answer should be very brief. -3.07. In the year 2008, what is the difference between the Claims(annual growth as % of broad money) of St. Kitts and Nevis and Claims(annual growth as % of broad money) of Sweden?
Offer a very short reply. -9.55. In the year 2009, what is the difference between the Claims(annual growth as % of broad money) in Congo (Republic) and Claims(annual growth as % of broad money) in Papua New Guinea?
Keep it short and to the point. -2.16. In the year 2009, what is the difference between the Claims(annual growth as % of broad money) in Congo (Republic) and Claims(annual growth as % of broad money) in St. Kitts and Nevis?
Provide a succinct answer. 2.35. In the year 2009, what is the difference between the Claims(annual growth as % of broad money) of Congo (Republic) and Claims(annual growth as % of broad money) of Sweden?
Keep it short and to the point. -0.03. In the year 2009, what is the difference between the Claims(annual growth as % of broad money) of Papua New Guinea and Claims(annual growth as % of broad money) of St. Kitts and Nevis?
Offer a terse response. 4.51. In the year 2009, what is the difference between the Claims(annual growth as % of broad money) in Papua New Guinea and Claims(annual growth as % of broad money) in Sweden?
Make the answer very short. 2.13. In the year 2009, what is the difference between the Claims(annual growth as % of broad money) of St. Kitts and Nevis and Claims(annual growth as % of broad money) of Sweden?
Provide a succinct answer. -2.38. What is the ratio of the Claims(annual growth as % of broad money) in Sweden in 2002 to that in 2003?
Provide a succinct answer. 1.03. What is the ratio of the Claims(annual growth as % of broad money) in Papua New Guinea in 2002 to that in 2004?
Keep it short and to the point. 1.56. What is the ratio of the Claims(annual growth as % of broad money) of Sweden in 2002 to that in 2004?
Give a very brief answer. 0.64. What is the ratio of the Claims(annual growth as % of broad money) of Papua New Guinea in 2002 to that in 2005?
Your answer should be compact. 0.07. What is the ratio of the Claims(annual growth as % of broad money) of Sweden in 2002 to that in 2005?
Ensure brevity in your answer.  0.33. What is the ratio of the Claims(annual growth as % of broad money) of Papua New Guinea in 2002 to that in 2006?
Your answer should be compact. 0.05. What is the ratio of the Claims(annual growth as % of broad money) in Sweden in 2002 to that in 2006?
Your answer should be compact. 0.41. What is the ratio of the Claims(annual growth as % of broad money) of Papua New Guinea in 2002 to that in 2007?
Your response must be concise. 0.05. What is the ratio of the Claims(annual growth as % of broad money) of Sweden in 2002 to that in 2007?
Keep it short and to the point. 0.29. What is the ratio of the Claims(annual growth as % of broad money) of Papua New Guinea in 2002 to that in 2008?
Provide a short and direct response. 0.06. What is the ratio of the Claims(annual growth as % of broad money) of Sweden in 2002 to that in 2008?
Provide a succinct answer. 0.51. What is the ratio of the Claims(annual growth as % of broad money) of Papua New Guinea in 2002 to that in 2009?
Your answer should be very brief. 0.09. What is the ratio of the Claims(annual growth as % of broad money) of Sweden in 2002 to that in 2009?
Your answer should be very brief. 1.39. What is the ratio of the Claims(annual growth as % of broad money) in St. Kitts and Nevis in 2003 to that in 2004?
Your answer should be compact. 0.5. What is the ratio of the Claims(annual growth as % of broad money) of Sweden in 2003 to that in 2004?
Make the answer very short. 0.62. What is the ratio of the Claims(annual growth as % of broad money) in Congo (Republic) in 2003 to that in 2005?
Your answer should be compact. 2.91. What is the ratio of the Claims(annual growth as % of broad money) of St. Kitts and Nevis in 2003 to that in 2005?
Make the answer very short. 0.64. What is the ratio of the Claims(annual growth as % of broad money) of Sweden in 2003 to that in 2005?
Your answer should be compact. 0.33. What is the ratio of the Claims(annual growth as % of broad money) in Congo (Republic) in 2003 to that in 2006?
Offer a very short reply. 2.94. What is the ratio of the Claims(annual growth as % of broad money) of St. Kitts and Nevis in 2003 to that in 2006?
Offer a very short reply. 0.4. What is the ratio of the Claims(annual growth as % of broad money) in Sweden in 2003 to that in 2006?
Your answer should be very brief. 0.4. What is the ratio of the Claims(annual growth as % of broad money) in Congo (Republic) in 2003 to that in 2007?
Make the answer very short. 4.9. What is the ratio of the Claims(annual growth as % of broad money) in St. Kitts and Nevis in 2003 to that in 2007?
Keep it short and to the point. 0.37. What is the ratio of the Claims(annual growth as % of broad money) in Sweden in 2003 to that in 2007?
Give a very brief answer. 0.29. What is the ratio of the Claims(annual growth as % of broad money) in Congo (Republic) in 2003 to that in 2008?
Give a very brief answer. 0.49. What is the ratio of the Claims(annual growth as % of broad money) of St. Kitts and Nevis in 2003 to that in 2008?
Provide a short and direct response. 0.35. What is the ratio of the Claims(annual growth as % of broad money) in Sweden in 2003 to that in 2008?
Give a very brief answer. 0.49. What is the ratio of the Claims(annual growth as % of broad money) in Congo (Republic) in 2003 to that in 2009?
Make the answer very short. 0.88. What is the ratio of the Claims(annual growth as % of broad money) of St. Kitts and Nevis in 2003 to that in 2009?
Offer a very short reply. 0.66. What is the ratio of the Claims(annual growth as % of broad money) in Sweden in 2003 to that in 2009?
Ensure brevity in your answer.  1.36. What is the ratio of the Claims(annual growth as % of broad money) in Papua New Guinea in 2004 to that in 2005?
Offer a very short reply. 0.05. What is the ratio of the Claims(annual growth as % of broad money) in St. Kitts and Nevis in 2004 to that in 2005?
Give a very brief answer. 1.27. What is the ratio of the Claims(annual growth as % of broad money) of Sweden in 2004 to that in 2005?
Your response must be concise. 0.53. What is the ratio of the Claims(annual growth as % of broad money) of Papua New Guinea in 2004 to that in 2006?
Give a very brief answer. 0.03. What is the ratio of the Claims(annual growth as % of broad money) in St. Kitts and Nevis in 2004 to that in 2006?
Your answer should be compact. 0.8. What is the ratio of the Claims(annual growth as % of broad money) of Sweden in 2004 to that in 2006?
Ensure brevity in your answer.  0.65. What is the ratio of the Claims(annual growth as % of broad money) in Papua New Guinea in 2004 to that in 2007?
Keep it short and to the point. 0.03. What is the ratio of the Claims(annual growth as % of broad money) of St. Kitts and Nevis in 2004 to that in 2007?
Keep it short and to the point. 0.73. What is the ratio of the Claims(annual growth as % of broad money) of Sweden in 2004 to that in 2007?
Ensure brevity in your answer.  0.46. What is the ratio of the Claims(annual growth as % of broad money) of Papua New Guinea in 2004 to that in 2008?
Your answer should be very brief. 0.04. What is the ratio of the Claims(annual growth as % of broad money) of St. Kitts and Nevis in 2004 to that in 2008?
Ensure brevity in your answer.  0.7. What is the ratio of the Claims(annual growth as % of broad money) of Sweden in 2004 to that in 2008?
Provide a succinct answer. 0.8. What is the ratio of the Claims(annual growth as % of broad money) in Papua New Guinea in 2004 to that in 2009?
Ensure brevity in your answer.  0.06. What is the ratio of the Claims(annual growth as % of broad money) of St. Kitts and Nevis in 2004 to that in 2009?
Your answer should be compact. 1.32. What is the ratio of the Claims(annual growth as % of broad money) of Sweden in 2004 to that in 2009?
Keep it short and to the point. 2.19. What is the ratio of the Claims(annual growth as % of broad money) of Congo (Republic) in 2005 to that in 2006?
Provide a short and direct response. 1.01. What is the ratio of the Claims(annual growth as % of broad money) in Papua New Guinea in 2005 to that in 2006?
Make the answer very short. 0.65. What is the ratio of the Claims(annual growth as % of broad money) of St. Kitts and Nevis in 2005 to that in 2006?
Your response must be concise. 0.63. What is the ratio of the Claims(annual growth as % of broad money) in Sweden in 2005 to that in 2006?
Keep it short and to the point. 1.24. What is the ratio of the Claims(annual growth as % of broad money) in Congo (Republic) in 2005 to that in 2007?
Offer a very short reply. 1.68. What is the ratio of the Claims(annual growth as % of broad money) in Papua New Guinea in 2005 to that in 2007?
Offer a very short reply. 0.73. What is the ratio of the Claims(annual growth as % of broad money) in St. Kitts and Nevis in 2005 to that in 2007?
Provide a short and direct response. 0.58. What is the ratio of the Claims(annual growth as % of broad money) of Sweden in 2005 to that in 2007?
Your answer should be very brief. 0.88. What is the ratio of the Claims(annual growth as % of broad money) in Papua New Guinea in 2005 to that in 2008?
Ensure brevity in your answer.  0.81. What is the ratio of the Claims(annual growth as % of broad money) in St. Kitts and Nevis in 2005 to that in 2008?
Make the answer very short. 0.55. What is the ratio of the Claims(annual growth as % of broad money) in Sweden in 2005 to that in 2008?
Offer a very short reply. 1.51. What is the ratio of the Claims(annual growth as % of broad money) in Congo (Republic) in 2005 to that in 2009?
Make the answer very short. 0.3. What is the ratio of the Claims(annual growth as % of broad money) in Papua New Guinea in 2005 to that in 2009?
Offer a very short reply. 1.31. What is the ratio of the Claims(annual growth as % of broad money) in St. Kitts and Nevis in 2005 to that in 2009?
Provide a succinct answer. 1.04. What is the ratio of the Claims(annual growth as % of broad money) in Sweden in 2005 to that in 2009?
Give a very brief answer. 4.16. What is the ratio of the Claims(annual growth as % of broad money) in Congo (Republic) in 2006 to that in 2007?
Provide a succinct answer. 1.66. What is the ratio of the Claims(annual growth as % of broad money) in Papua New Guinea in 2006 to that in 2007?
Offer a terse response. 1.12. What is the ratio of the Claims(annual growth as % of broad money) in St. Kitts and Nevis in 2006 to that in 2007?
Offer a terse response. 0.91. What is the ratio of the Claims(annual growth as % of broad money) in Sweden in 2006 to that in 2007?
Give a very brief answer. 0.71. What is the ratio of the Claims(annual growth as % of broad money) of Congo (Republic) in 2006 to that in 2008?
Provide a succinct answer. 0.16. What is the ratio of the Claims(annual growth as % of broad money) of Papua New Guinea in 2006 to that in 2008?
Ensure brevity in your answer.  1.24. What is the ratio of the Claims(annual growth as % of broad money) in St. Kitts and Nevis in 2006 to that in 2008?
Keep it short and to the point. 0.88. What is the ratio of the Claims(annual growth as % of broad money) of Sweden in 2006 to that in 2008?
Provide a succinct answer. 1.22. What is the ratio of the Claims(annual growth as % of broad money) in Congo (Republic) in 2006 to that in 2009?
Your answer should be very brief. 0.3. What is the ratio of the Claims(annual growth as % of broad money) of Papua New Guinea in 2006 to that in 2009?
Ensure brevity in your answer.  2.02. What is the ratio of the Claims(annual growth as % of broad money) in St. Kitts and Nevis in 2006 to that in 2009?
Provide a succinct answer. 1.65. What is the ratio of the Claims(annual growth as % of broad money) of Sweden in 2006 to that in 2009?
Offer a very short reply. 3.35. What is the ratio of the Claims(annual growth as % of broad money) in Congo (Republic) in 2007 to that in 2008?
Your answer should be very brief. 0.1. What is the ratio of the Claims(annual growth as % of broad money) of Papua New Guinea in 2007 to that in 2008?
Provide a short and direct response. 1.11. What is the ratio of the Claims(annual growth as % of broad money) of St. Kitts and Nevis in 2007 to that in 2008?
Provide a succinct answer. 0.96. What is the ratio of the Claims(annual growth as % of broad money) of Sweden in 2007 to that in 2008?
Your response must be concise. 1.72. What is the ratio of the Claims(annual growth as % of broad money) in Congo (Republic) in 2007 to that in 2009?
Make the answer very short. 0.18. What is the ratio of the Claims(annual growth as % of broad money) of Papua New Guinea in 2007 to that in 2009?
Make the answer very short. 1.8. What is the ratio of the Claims(annual growth as % of broad money) in St. Kitts and Nevis in 2007 to that in 2009?
Provide a succinct answer. 1.81. What is the ratio of the Claims(annual growth as % of broad money) of Sweden in 2007 to that in 2009?
Provide a succinct answer. 4.74. What is the ratio of the Claims(annual growth as % of broad money) of Congo (Republic) in 2008 to that in 2009?
Give a very brief answer. 1.8. What is the ratio of the Claims(annual growth as % of broad money) of Papua New Guinea in 2008 to that in 2009?
Provide a short and direct response. 1.63. What is the ratio of the Claims(annual growth as % of broad money) in St. Kitts and Nevis in 2008 to that in 2009?
Your response must be concise. 1.88. What is the ratio of the Claims(annual growth as % of broad money) in Sweden in 2008 to that in 2009?
Provide a succinct answer. 2.75. What is the difference between the highest and the second highest Claims(annual growth as % of broad money) of Congo (Republic)?
Give a very brief answer. 4.67. What is the difference between the highest and the second highest Claims(annual growth as % of broad money) in Papua New Guinea?
Your answer should be very brief. 1.72. What is the difference between the highest and the second highest Claims(annual growth as % of broad money) in St. Kitts and Nevis?
Your answer should be compact. 0.25. What is the difference between the highest and the second highest Claims(annual growth as % of broad money) in Sweden?
Keep it short and to the point. 3.37. What is the difference between the highest and the lowest Claims(annual growth as % of broad money) of Congo (Republic)?
Keep it short and to the point. 10.47. What is the difference between the highest and the lowest Claims(annual growth as % of broad money) in Papua New Guinea?
Give a very brief answer. 16.1. What is the difference between the highest and the lowest Claims(annual growth as % of broad money) in St. Kitts and Nevis?
Provide a succinct answer. 6.5. What is the difference between the highest and the lowest Claims(annual growth as % of broad money) in Sweden?
Ensure brevity in your answer.  21.82. 